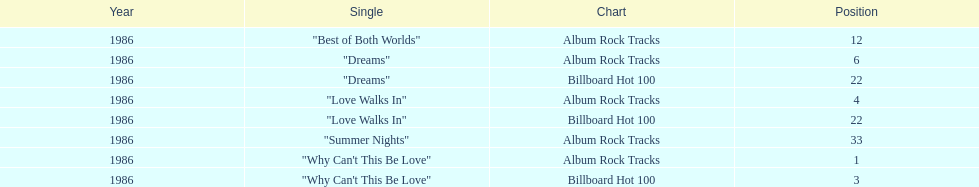Which is the most popular single on the album? Why Can't This Be Love. 